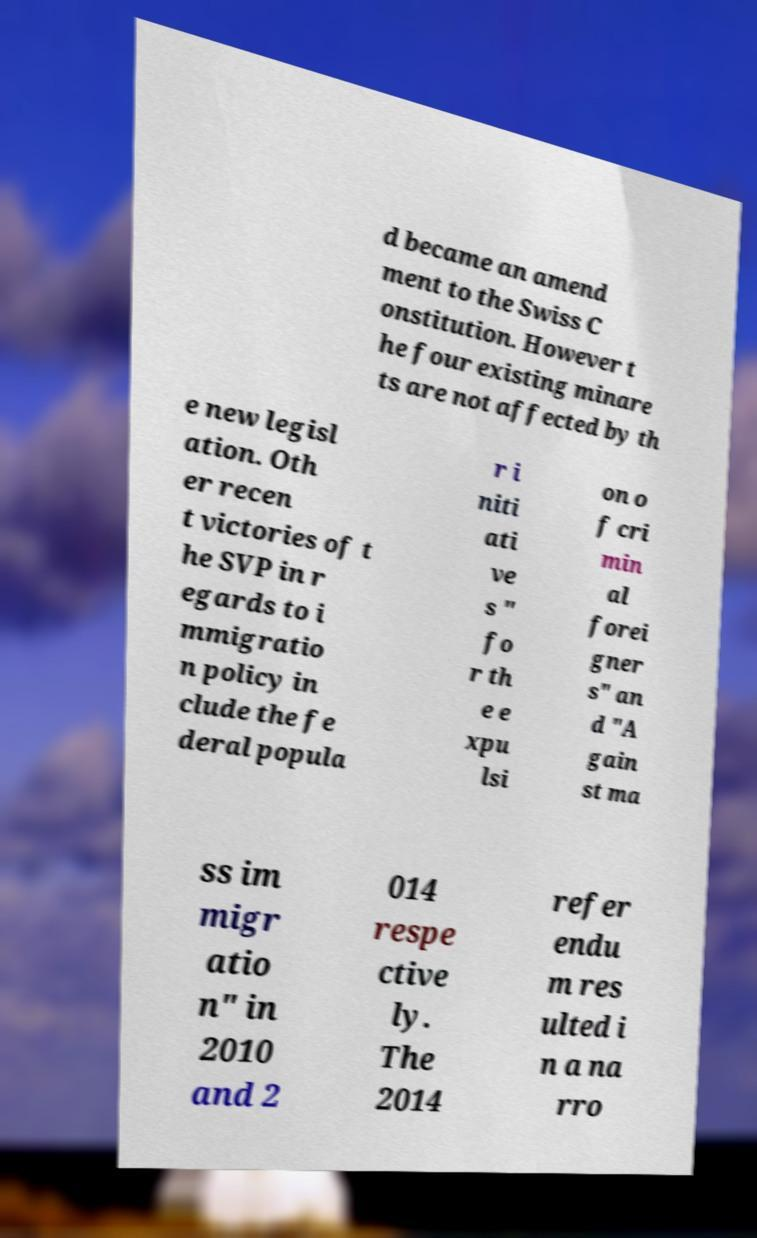There's text embedded in this image that I need extracted. Can you transcribe it verbatim? d became an amend ment to the Swiss C onstitution. However t he four existing minare ts are not affected by th e new legisl ation. Oth er recen t victories of t he SVP in r egards to i mmigratio n policy in clude the fe deral popula r i niti ati ve s " fo r th e e xpu lsi on o f cri min al forei gner s" an d "A gain st ma ss im migr atio n" in 2010 and 2 014 respe ctive ly. The 2014 refer endu m res ulted i n a na rro 